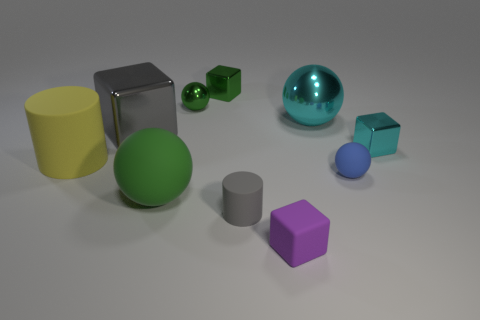Is there a large gray metal cube in front of the cylinder that is in front of the big object that is in front of the large yellow rubber thing?
Provide a short and direct response. No. What material is the purple thing that is the same shape as the small cyan metal thing?
Offer a very short reply. Rubber. Is there anything else that has the same material as the cyan cube?
Your response must be concise. Yes. Do the yellow cylinder and the gray thing that is behind the tiny blue thing have the same material?
Keep it short and to the point. No. What is the shape of the cyan shiny thing that is right of the small sphere that is in front of the cyan ball?
Your answer should be compact. Cube. What number of big objects are yellow rubber balls or metal blocks?
Ensure brevity in your answer.  1. What number of green things are the same shape as the blue thing?
Ensure brevity in your answer.  2. Is the shape of the small purple thing the same as the tiny matte object on the left side of the purple rubber block?
Make the answer very short. No. What number of small matte cubes are on the left side of the big yellow rubber thing?
Your answer should be very brief. 0. Is there a yellow sphere that has the same size as the gray metallic cube?
Provide a short and direct response. No. 